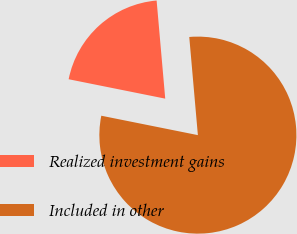Convert chart to OTSL. <chart><loc_0><loc_0><loc_500><loc_500><pie_chart><fcel>Realized investment gains<fcel>Included in other<nl><fcel>20.45%<fcel>79.55%<nl></chart> 